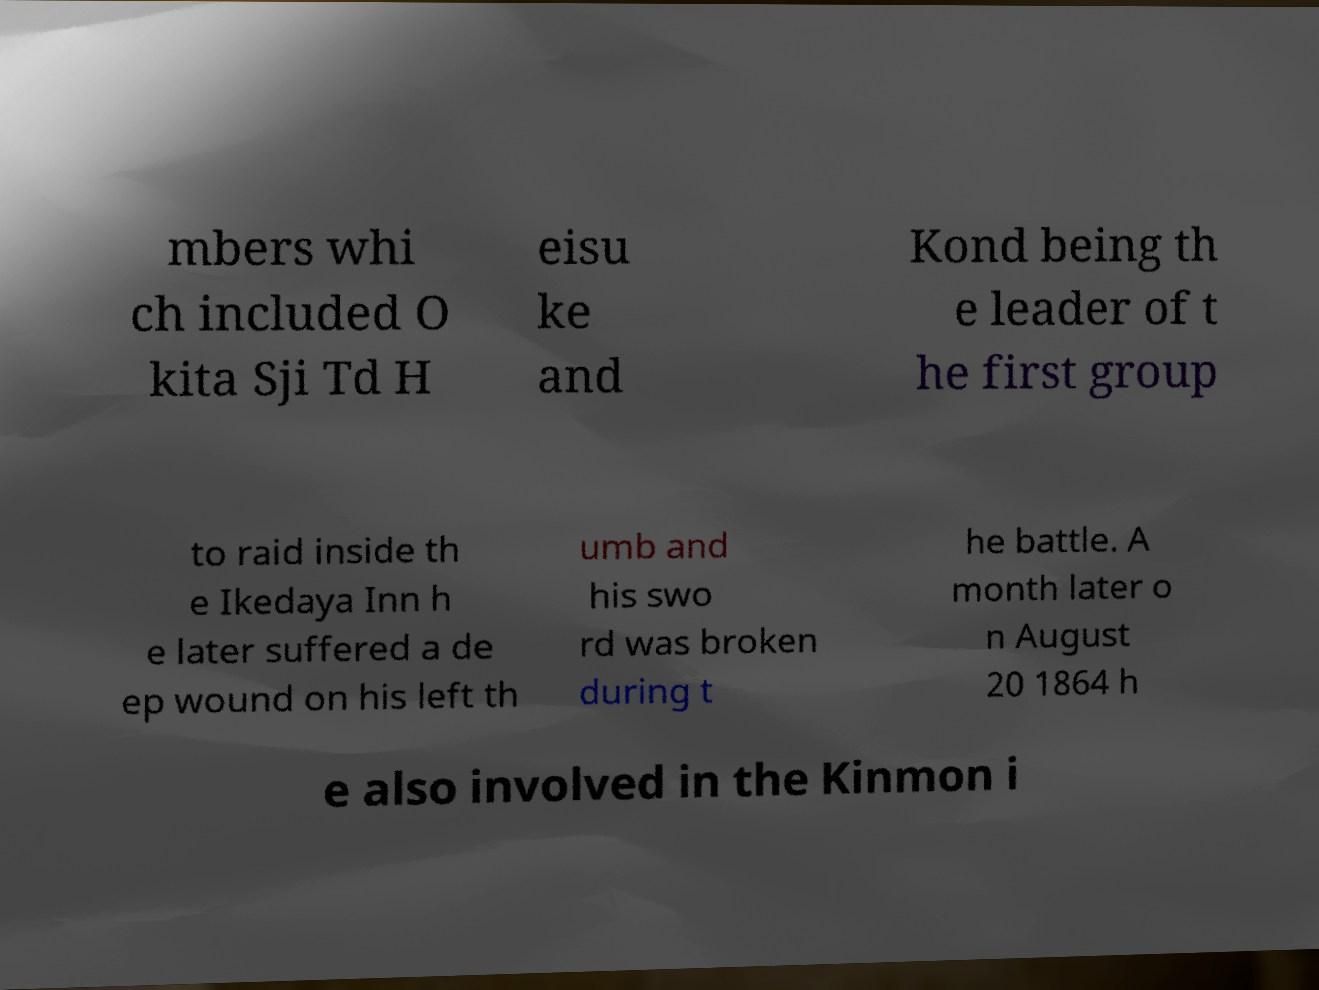Please identify and transcribe the text found in this image. mbers whi ch included O kita Sji Td H eisu ke and Kond being th e leader of t he first group to raid inside th e Ikedaya Inn h e later suffered a de ep wound on his left th umb and his swo rd was broken during t he battle. A month later o n August 20 1864 h e also involved in the Kinmon i 